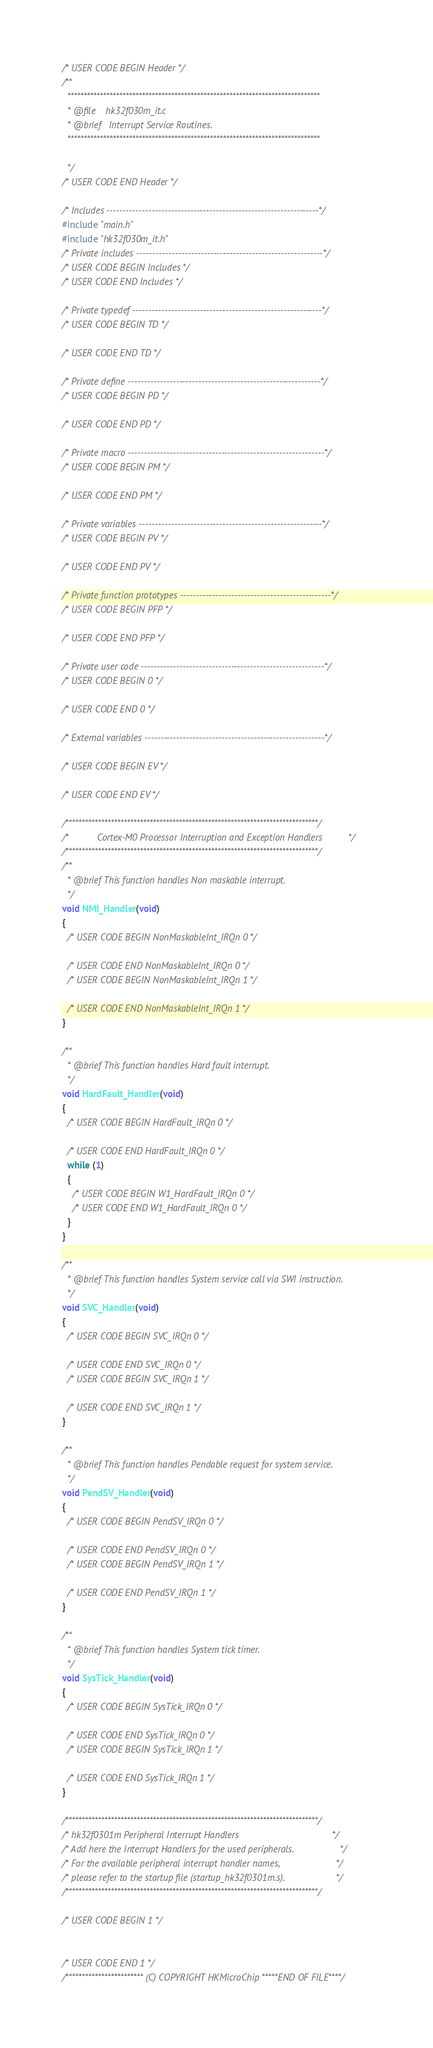Convert code to text. <code><loc_0><loc_0><loc_500><loc_500><_C_>/* USER CODE BEGIN Header */
/**
  ******************************************************************************
  * @file    hk32f030m_it.c
  * @brief   Interrupt Service Routines.
  ******************************************************************************

  */
/* USER CODE END Header */

/* Includes ------------------------------------------------------------------*/
#include "main.h"
#include "hk32f030m_it.h"
/* Private includes ----------------------------------------------------------*/
/* USER CODE BEGIN Includes */
/* USER CODE END Includes */

/* Private typedef -----------------------------------------------------------*/
/* USER CODE BEGIN TD */

/* USER CODE END TD */

/* Private define ------------------------------------------------------------*/
/* USER CODE BEGIN PD */
 
/* USER CODE END PD */

/* Private macro -------------------------------------------------------------*/
/* USER CODE BEGIN PM */

/* USER CODE END PM */

/* Private variables ---------------------------------------------------------*/
/* USER CODE BEGIN PV */

/* USER CODE END PV */

/* Private function prototypes -----------------------------------------------*/
/* USER CODE BEGIN PFP */

/* USER CODE END PFP */

/* Private user code ---------------------------------------------------------*/
/* USER CODE BEGIN 0 */

/* USER CODE END 0 */

/* External variables --------------------------------------------------------*/

/* USER CODE BEGIN EV */

/* USER CODE END EV */

/******************************************************************************/
/*           Cortex-M0 Processor Interruption and Exception Handlers          */ 
/******************************************************************************/
/**
  * @brief This function handles Non maskable interrupt.
  */
void NMI_Handler(void)
{
  /* USER CODE BEGIN NonMaskableInt_IRQn 0 */

  /* USER CODE END NonMaskableInt_IRQn 0 */
  /* USER CODE BEGIN NonMaskableInt_IRQn 1 */

  /* USER CODE END NonMaskableInt_IRQn 1 */
}

/**
  * @brief This function handles Hard fault interrupt.
  */
void HardFault_Handler(void)
{
  /* USER CODE BEGIN HardFault_IRQn 0 */

  /* USER CODE END HardFault_IRQn 0 */
  while (1)
  {
    /* USER CODE BEGIN W1_HardFault_IRQn 0 */
    /* USER CODE END W1_HardFault_IRQn 0 */
  }
}

/**
  * @brief This function handles System service call via SWI instruction.
  */
void SVC_Handler(void)
{
  /* USER CODE BEGIN SVC_IRQn 0 */

  /* USER CODE END SVC_IRQn 0 */
  /* USER CODE BEGIN SVC_IRQn 1 */

  /* USER CODE END SVC_IRQn 1 */
}

/**
  * @brief This function handles Pendable request for system service.
  */
void PendSV_Handler(void)
{
  /* USER CODE BEGIN PendSV_IRQn 0 */

  /* USER CODE END PendSV_IRQn 0 */
  /* USER CODE BEGIN PendSV_IRQn 1 */

  /* USER CODE END PendSV_IRQn 1 */
}

/**
  * @brief This function handles System tick timer.
  */
void SysTick_Handler(void)
{
  /* USER CODE BEGIN SysTick_IRQn 0 */

  /* USER CODE END SysTick_IRQn 0 */
  /* USER CODE BEGIN SysTick_IRQn 1 */

  /* USER CODE END SysTick_IRQn 1 */
}

/******************************************************************************/
/* hk32f0301m Peripheral Interrupt Handlers                                    */
/* Add here the Interrupt Handlers for the used peripherals.                  */
/* For the available peripheral interrupt handler names,                      */
/* please refer to the startup file (startup_hk32f0301m.s).                    */
/******************************************************************************/

/* USER CODE BEGIN 1 */

 
/* USER CODE END 1 */
/************************ (C) COPYRIGHT HKMicroChip *****END OF FILE****/
</code> 